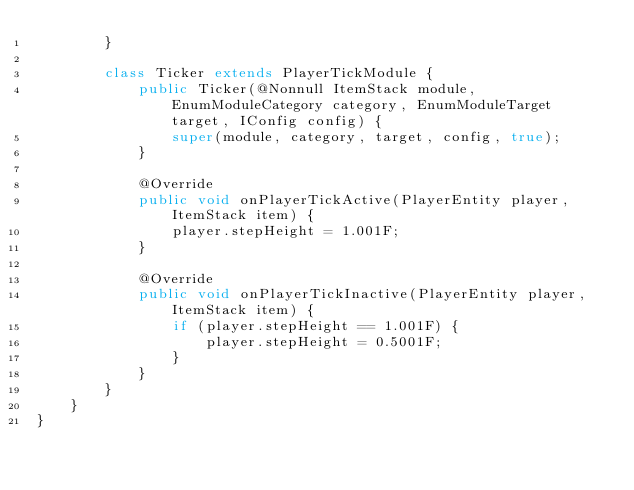Convert code to text. <code><loc_0><loc_0><loc_500><loc_500><_Java_>        }

        class Ticker extends PlayerTickModule {
            public Ticker(@Nonnull ItemStack module, EnumModuleCategory category, EnumModuleTarget target, IConfig config) {
                super(module, category, target, config, true);
            }

            @Override
            public void onPlayerTickActive(PlayerEntity player, ItemStack item) {
                player.stepHeight = 1.001F;
            }

            @Override
            public void onPlayerTickInactive(PlayerEntity player, ItemStack item) {
                if (player.stepHeight == 1.001F) {
                    player.stepHeight = 0.5001F;
                }
            }
        }
    }
}</code> 